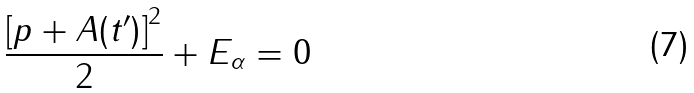Convert formula to latex. <formula><loc_0><loc_0><loc_500><loc_500>\frac { \left [ p + A ( t ^ { \prime } ) \right ] ^ { 2 } } { 2 } + E _ { \alpha } = 0</formula> 